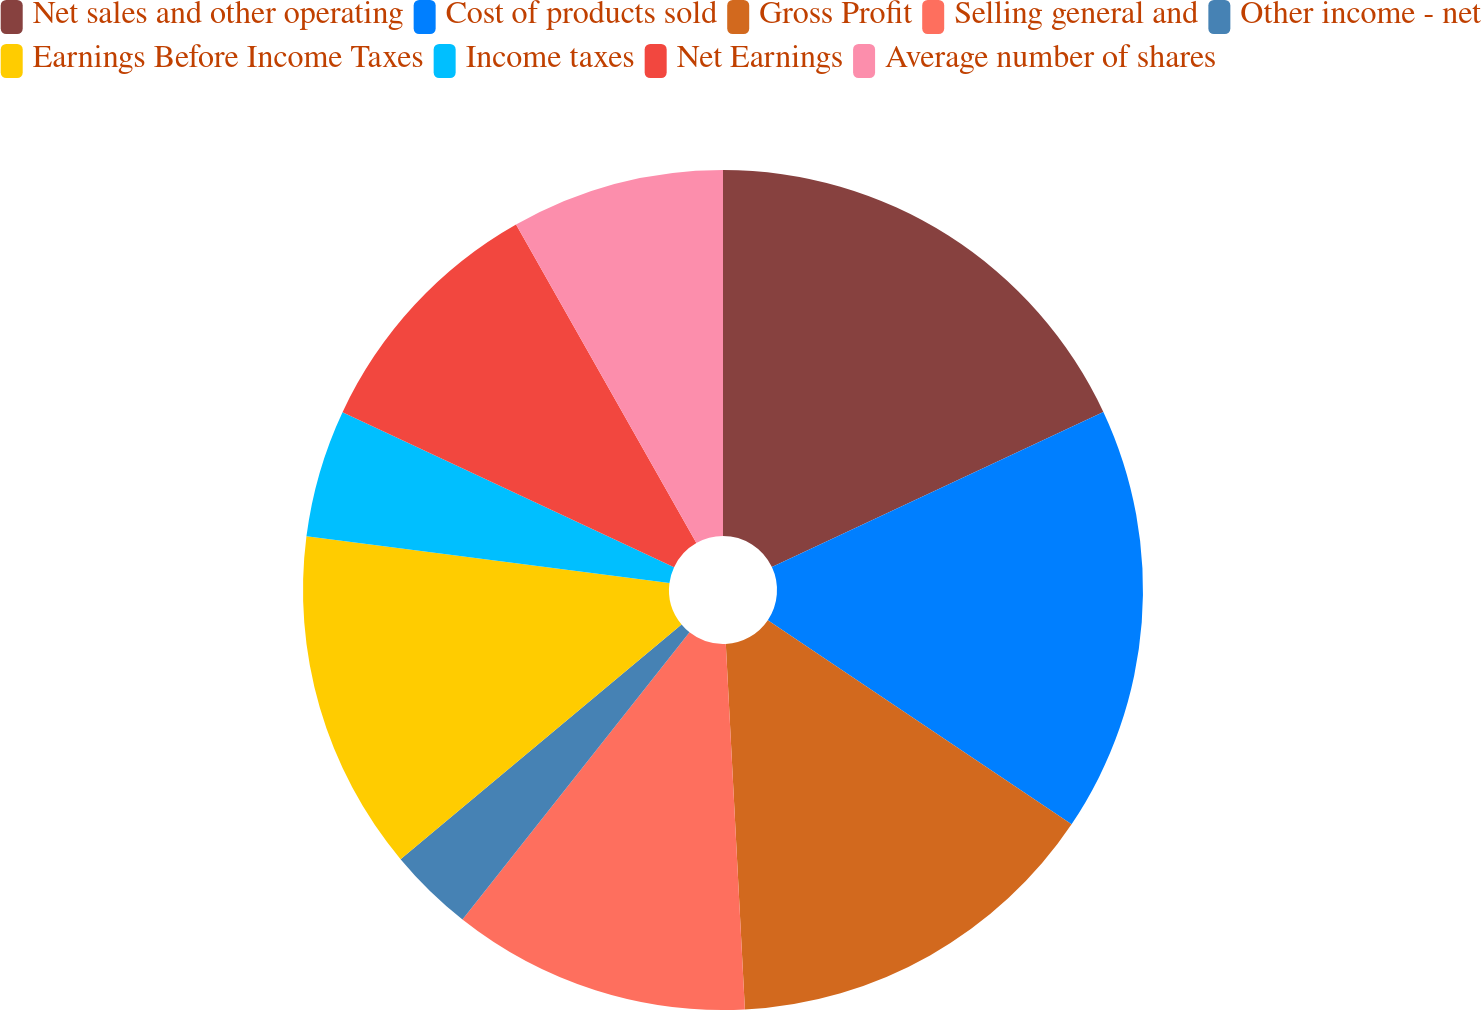Convert chart to OTSL. <chart><loc_0><loc_0><loc_500><loc_500><pie_chart><fcel>Net sales and other operating<fcel>Cost of products sold<fcel>Gross Profit<fcel>Selling general and<fcel>Other income - net<fcel>Earnings Before Income Taxes<fcel>Income taxes<fcel>Net Earnings<fcel>Average number of shares<nl><fcel>18.03%<fcel>16.39%<fcel>14.75%<fcel>11.48%<fcel>3.28%<fcel>13.11%<fcel>4.92%<fcel>9.84%<fcel>8.2%<nl></chart> 